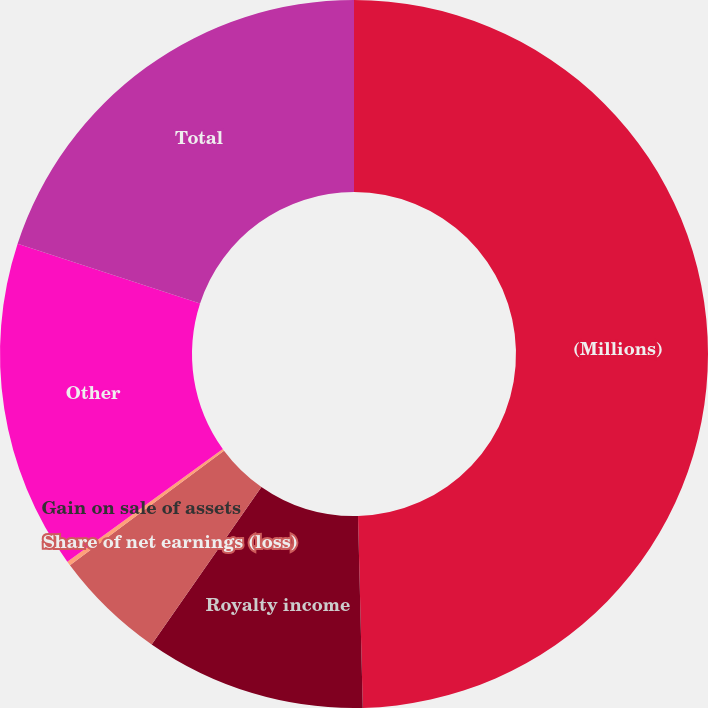Convert chart. <chart><loc_0><loc_0><loc_500><loc_500><pie_chart><fcel>(Millions)<fcel>Royalty income<fcel>Share of net earnings (loss)<fcel>Gain on sale of assets<fcel>Other<fcel>Total<nl><fcel>49.61%<fcel>10.08%<fcel>5.14%<fcel>0.2%<fcel>15.02%<fcel>19.96%<nl></chart> 